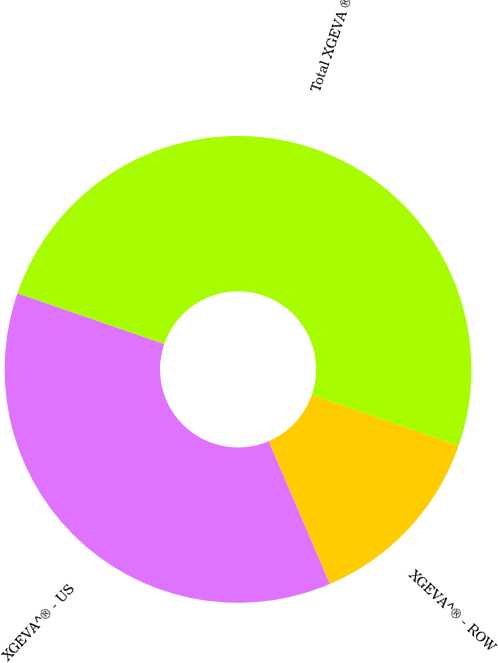Convert chart. <chart><loc_0><loc_0><loc_500><loc_500><pie_chart><fcel>XGEVA^® - US<fcel>XGEVA^® - ROW<fcel>Total XGEVA ®<nl><fcel>36.73%<fcel>13.27%<fcel>50.0%<nl></chart> 